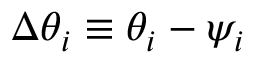<formula> <loc_0><loc_0><loc_500><loc_500>\Delta \theta _ { i } \equiv \theta _ { i } - \psi _ { i }</formula> 